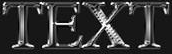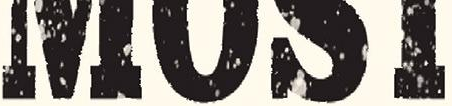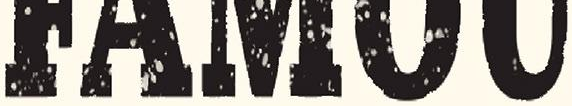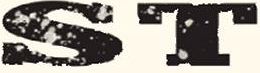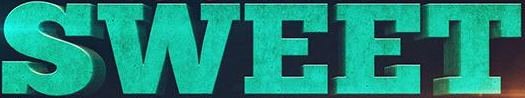Read the text content from these images in order, separated by a semicolon. TEXT; ####; #####; ST; SWEET 